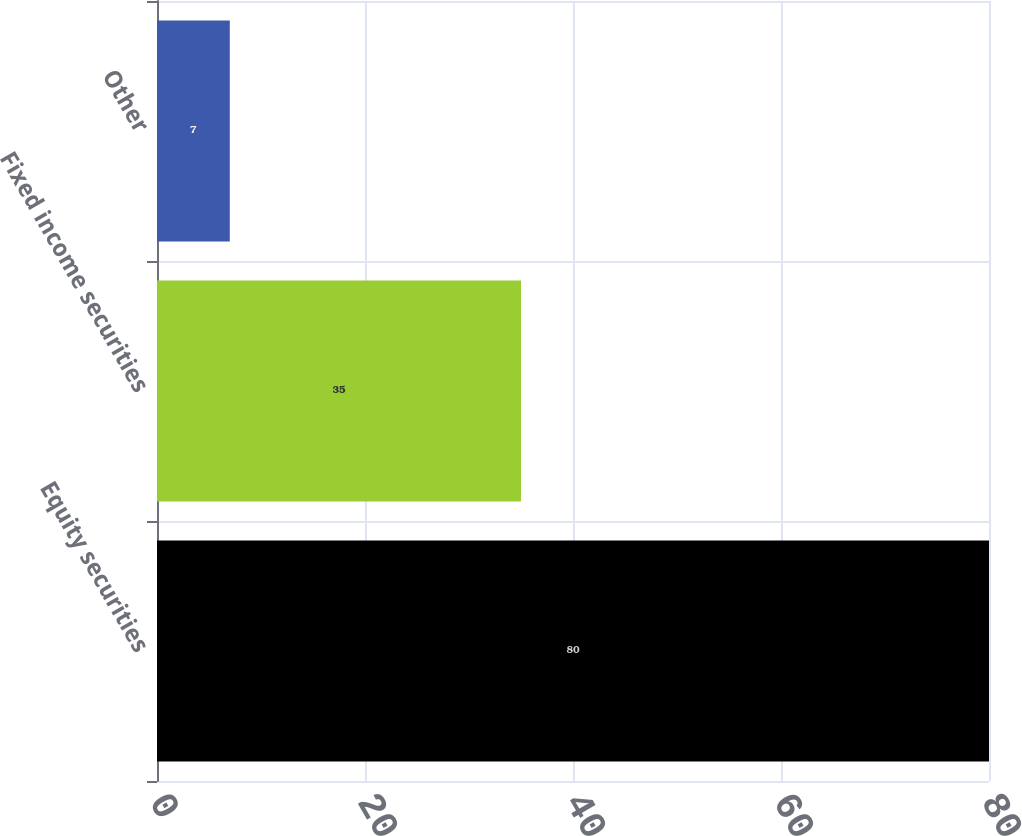<chart> <loc_0><loc_0><loc_500><loc_500><bar_chart><fcel>Equity securities<fcel>Fixed income securities<fcel>Other<nl><fcel>80<fcel>35<fcel>7<nl></chart> 